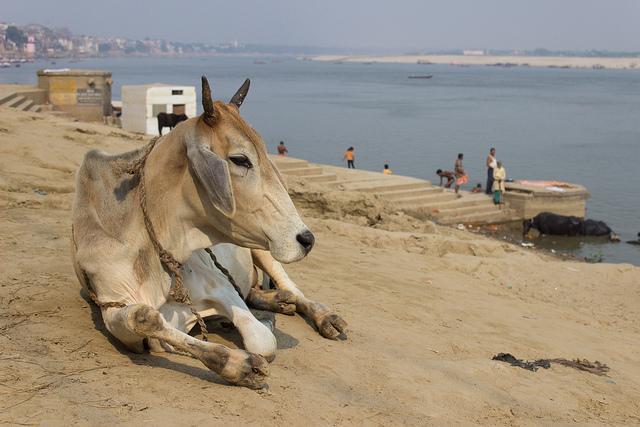How many horns?
Give a very brief answer. 2. How many big orange are there in the image ?
Give a very brief answer. 0. 